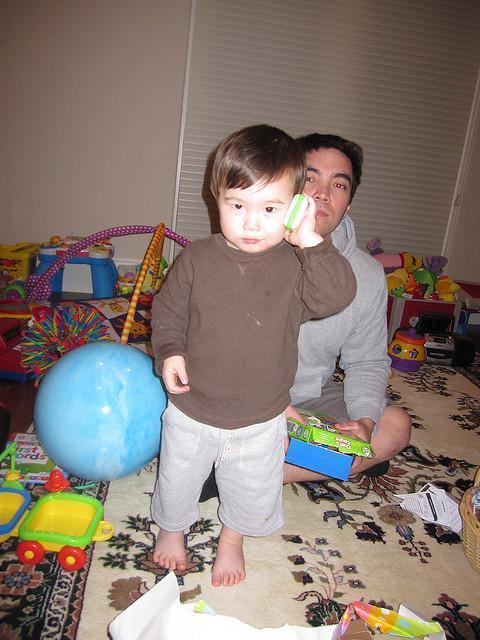How many people are there?
Give a very brief answer. 2. How many beds are visible?
Give a very brief answer. 1. How many buses are solid blue?
Give a very brief answer. 0. 